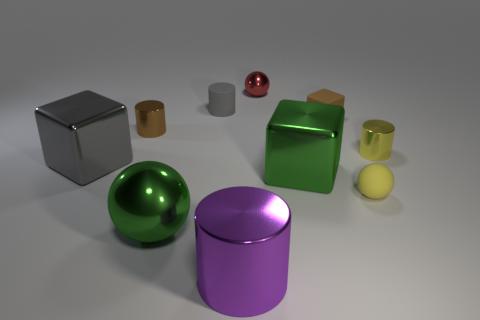Subtract all spheres. How many objects are left? 7 Add 3 tiny matte balls. How many tiny matte balls are left? 4 Add 3 small red shiny cubes. How many small red shiny cubes exist? 3 Subtract 1 red spheres. How many objects are left? 9 Subtract all red metallic objects. Subtract all small brown objects. How many objects are left? 7 